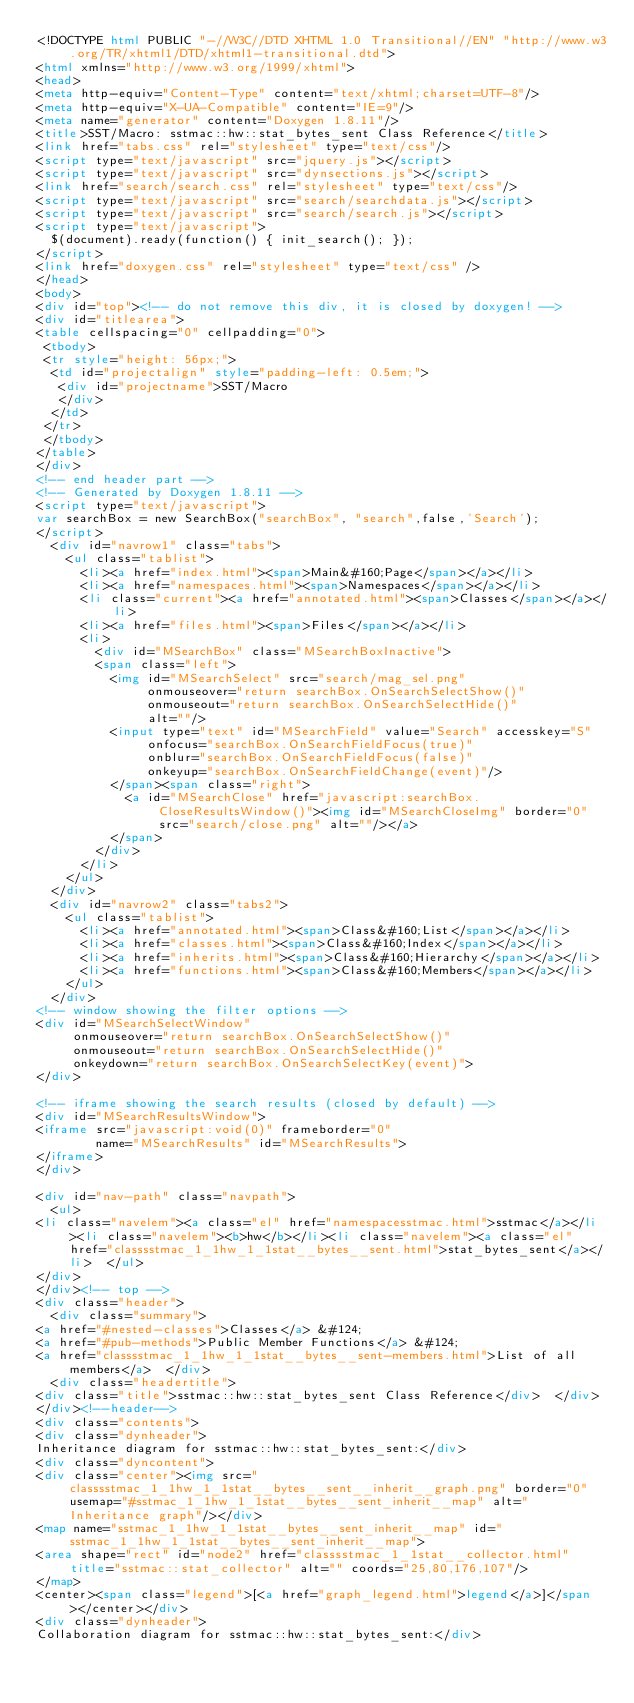<code> <loc_0><loc_0><loc_500><loc_500><_HTML_><!DOCTYPE html PUBLIC "-//W3C//DTD XHTML 1.0 Transitional//EN" "http://www.w3.org/TR/xhtml1/DTD/xhtml1-transitional.dtd">
<html xmlns="http://www.w3.org/1999/xhtml">
<head>
<meta http-equiv="Content-Type" content="text/xhtml;charset=UTF-8"/>
<meta http-equiv="X-UA-Compatible" content="IE=9"/>
<meta name="generator" content="Doxygen 1.8.11"/>
<title>SST/Macro: sstmac::hw::stat_bytes_sent Class Reference</title>
<link href="tabs.css" rel="stylesheet" type="text/css"/>
<script type="text/javascript" src="jquery.js"></script>
<script type="text/javascript" src="dynsections.js"></script>
<link href="search/search.css" rel="stylesheet" type="text/css"/>
<script type="text/javascript" src="search/searchdata.js"></script>
<script type="text/javascript" src="search/search.js"></script>
<script type="text/javascript">
  $(document).ready(function() { init_search(); });
</script>
<link href="doxygen.css" rel="stylesheet" type="text/css" />
</head>
<body>
<div id="top"><!-- do not remove this div, it is closed by doxygen! -->
<div id="titlearea">
<table cellspacing="0" cellpadding="0">
 <tbody>
 <tr style="height: 56px;">
  <td id="projectalign" style="padding-left: 0.5em;">
   <div id="projectname">SST/Macro
   </div>
  </td>
 </tr>
 </tbody>
</table>
</div>
<!-- end header part -->
<!-- Generated by Doxygen 1.8.11 -->
<script type="text/javascript">
var searchBox = new SearchBox("searchBox", "search",false,'Search');
</script>
  <div id="navrow1" class="tabs">
    <ul class="tablist">
      <li><a href="index.html"><span>Main&#160;Page</span></a></li>
      <li><a href="namespaces.html"><span>Namespaces</span></a></li>
      <li class="current"><a href="annotated.html"><span>Classes</span></a></li>
      <li><a href="files.html"><span>Files</span></a></li>
      <li>
        <div id="MSearchBox" class="MSearchBoxInactive">
        <span class="left">
          <img id="MSearchSelect" src="search/mag_sel.png"
               onmouseover="return searchBox.OnSearchSelectShow()"
               onmouseout="return searchBox.OnSearchSelectHide()"
               alt=""/>
          <input type="text" id="MSearchField" value="Search" accesskey="S"
               onfocus="searchBox.OnSearchFieldFocus(true)" 
               onblur="searchBox.OnSearchFieldFocus(false)" 
               onkeyup="searchBox.OnSearchFieldChange(event)"/>
          </span><span class="right">
            <a id="MSearchClose" href="javascript:searchBox.CloseResultsWindow()"><img id="MSearchCloseImg" border="0" src="search/close.png" alt=""/></a>
          </span>
        </div>
      </li>
    </ul>
  </div>
  <div id="navrow2" class="tabs2">
    <ul class="tablist">
      <li><a href="annotated.html"><span>Class&#160;List</span></a></li>
      <li><a href="classes.html"><span>Class&#160;Index</span></a></li>
      <li><a href="inherits.html"><span>Class&#160;Hierarchy</span></a></li>
      <li><a href="functions.html"><span>Class&#160;Members</span></a></li>
    </ul>
  </div>
<!-- window showing the filter options -->
<div id="MSearchSelectWindow"
     onmouseover="return searchBox.OnSearchSelectShow()"
     onmouseout="return searchBox.OnSearchSelectHide()"
     onkeydown="return searchBox.OnSearchSelectKey(event)">
</div>

<!-- iframe showing the search results (closed by default) -->
<div id="MSearchResultsWindow">
<iframe src="javascript:void(0)" frameborder="0" 
        name="MSearchResults" id="MSearchResults">
</iframe>
</div>

<div id="nav-path" class="navpath">
  <ul>
<li class="navelem"><a class="el" href="namespacesstmac.html">sstmac</a></li><li class="navelem"><b>hw</b></li><li class="navelem"><a class="el" href="classsstmac_1_1hw_1_1stat__bytes__sent.html">stat_bytes_sent</a></li>  </ul>
</div>
</div><!-- top -->
<div class="header">
  <div class="summary">
<a href="#nested-classes">Classes</a> &#124;
<a href="#pub-methods">Public Member Functions</a> &#124;
<a href="classsstmac_1_1hw_1_1stat__bytes__sent-members.html">List of all members</a>  </div>
  <div class="headertitle">
<div class="title">sstmac::hw::stat_bytes_sent Class Reference</div>  </div>
</div><!--header-->
<div class="contents">
<div class="dynheader">
Inheritance diagram for sstmac::hw::stat_bytes_sent:</div>
<div class="dyncontent">
<div class="center"><img src="classsstmac_1_1hw_1_1stat__bytes__sent__inherit__graph.png" border="0" usemap="#sstmac_1_1hw_1_1stat__bytes__sent_inherit__map" alt="Inheritance graph"/></div>
<map name="sstmac_1_1hw_1_1stat__bytes__sent_inherit__map" id="sstmac_1_1hw_1_1stat__bytes__sent_inherit__map">
<area shape="rect" id="node2" href="classsstmac_1_1stat__collector.html" title="sstmac::stat_collector" alt="" coords="25,80,176,107"/>
</map>
<center><span class="legend">[<a href="graph_legend.html">legend</a>]</span></center></div>
<div class="dynheader">
Collaboration diagram for sstmac::hw::stat_bytes_sent:</div></code> 